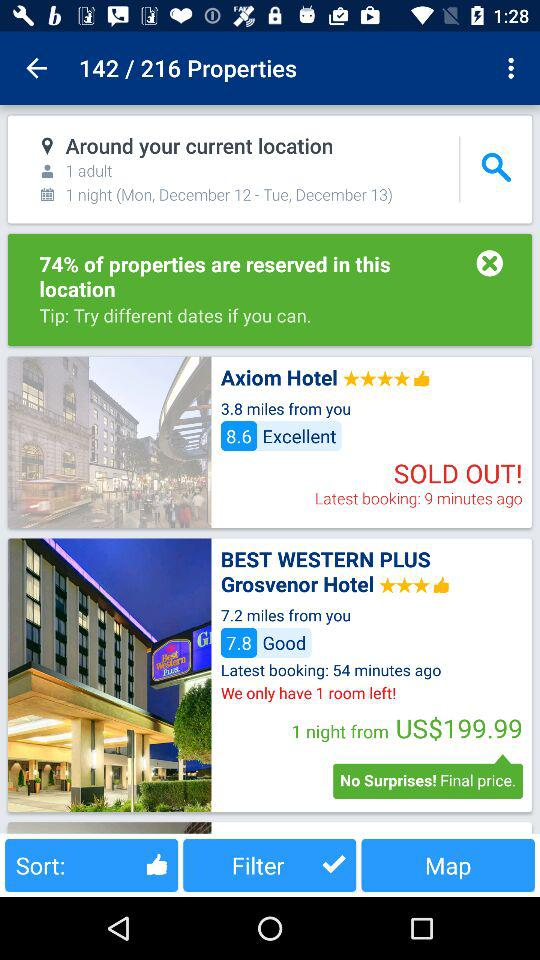How many minutes ago was the latest booking for the Axiom hotel? The latest booking for the Axiom hotel was made 9 minutes ago. 